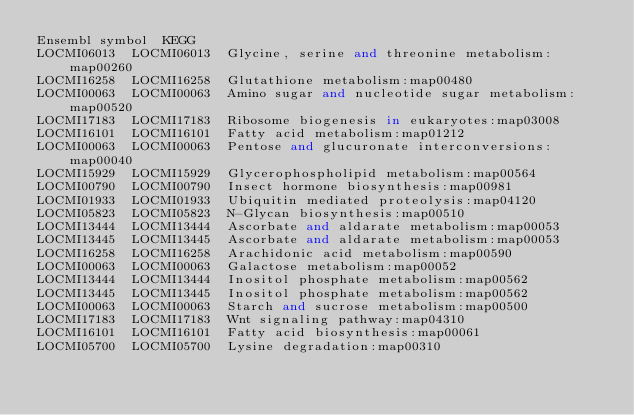<code> <loc_0><loc_0><loc_500><loc_500><_SQL_>Ensembl	symbol	KEGG
LOCMI06013	LOCMI06013	Glycine, serine and threonine metabolism:map00260
LOCMI16258	LOCMI16258	Glutathione metabolism:map00480
LOCMI00063	LOCMI00063	Amino sugar and nucleotide sugar metabolism:map00520
LOCMI17183	LOCMI17183	Ribosome biogenesis in eukaryotes:map03008
LOCMI16101	LOCMI16101	Fatty acid metabolism:map01212
LOCMI00063	LOCMI00063	Pentose and glucuronate interconversions:map00040
LOCMI15929	LOCMI15929	Glycerophospholipid metabolism:map00564
LOCMI00790	LOCMI00790	Insect hormone biosynthesis:map00981
LOCMI01933	LOCMI01933	Ubiquitin mediated proteolysis:map04120
LOCMI05823	LOCMI05823	N-Glycan biosynthesis:map00510
LOCMI13444	LOCMI13444	Ascorbate and aldarate metabolism:map00053
LOCMI13445	LOCMI13445	Ascorbate and aldarate metabolism:map00053
LOCMI16258	LOCMI16258	Arachidonic acid metabolism:map00590
LOCMI00063	LOCMI00063	Galactose metabolism:map00052
LOCMI13444	LOCMI13444	Inositol phosphate metabolism:map00562
LOCMI13445	LOCMI13445	Inositol phosphate metabolism:map00562
LOCMI00063	LOCMI00063	Starch and sucrose metabolism:map00500
LOCMI17183	LOCMI17183	Wnt signaling pathway:map04310
LOCMI16101	LOCMI16101	Fatty acid biosynthesis:map00061
LOCMI05700	LOCMI05700	Lysine degradation:map00310
</code> 